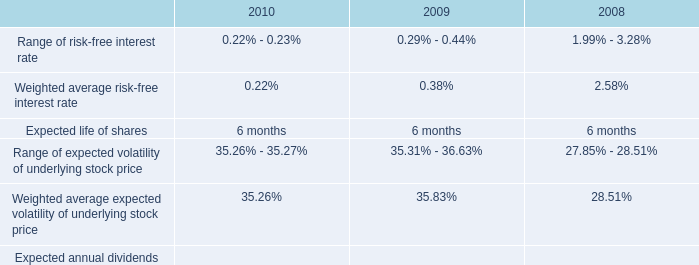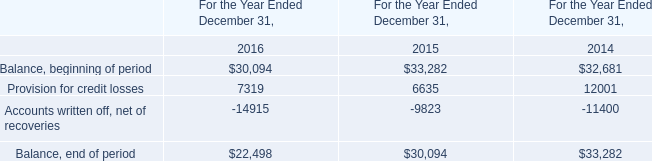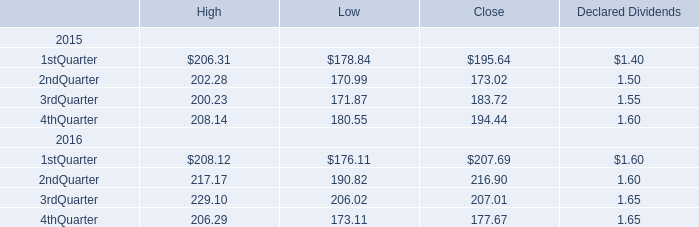what is the total cash received from shares purchased from employees during 2010 , in millions? 
Computations: (75354 * 34.16)
Answer: 2574092.64. 